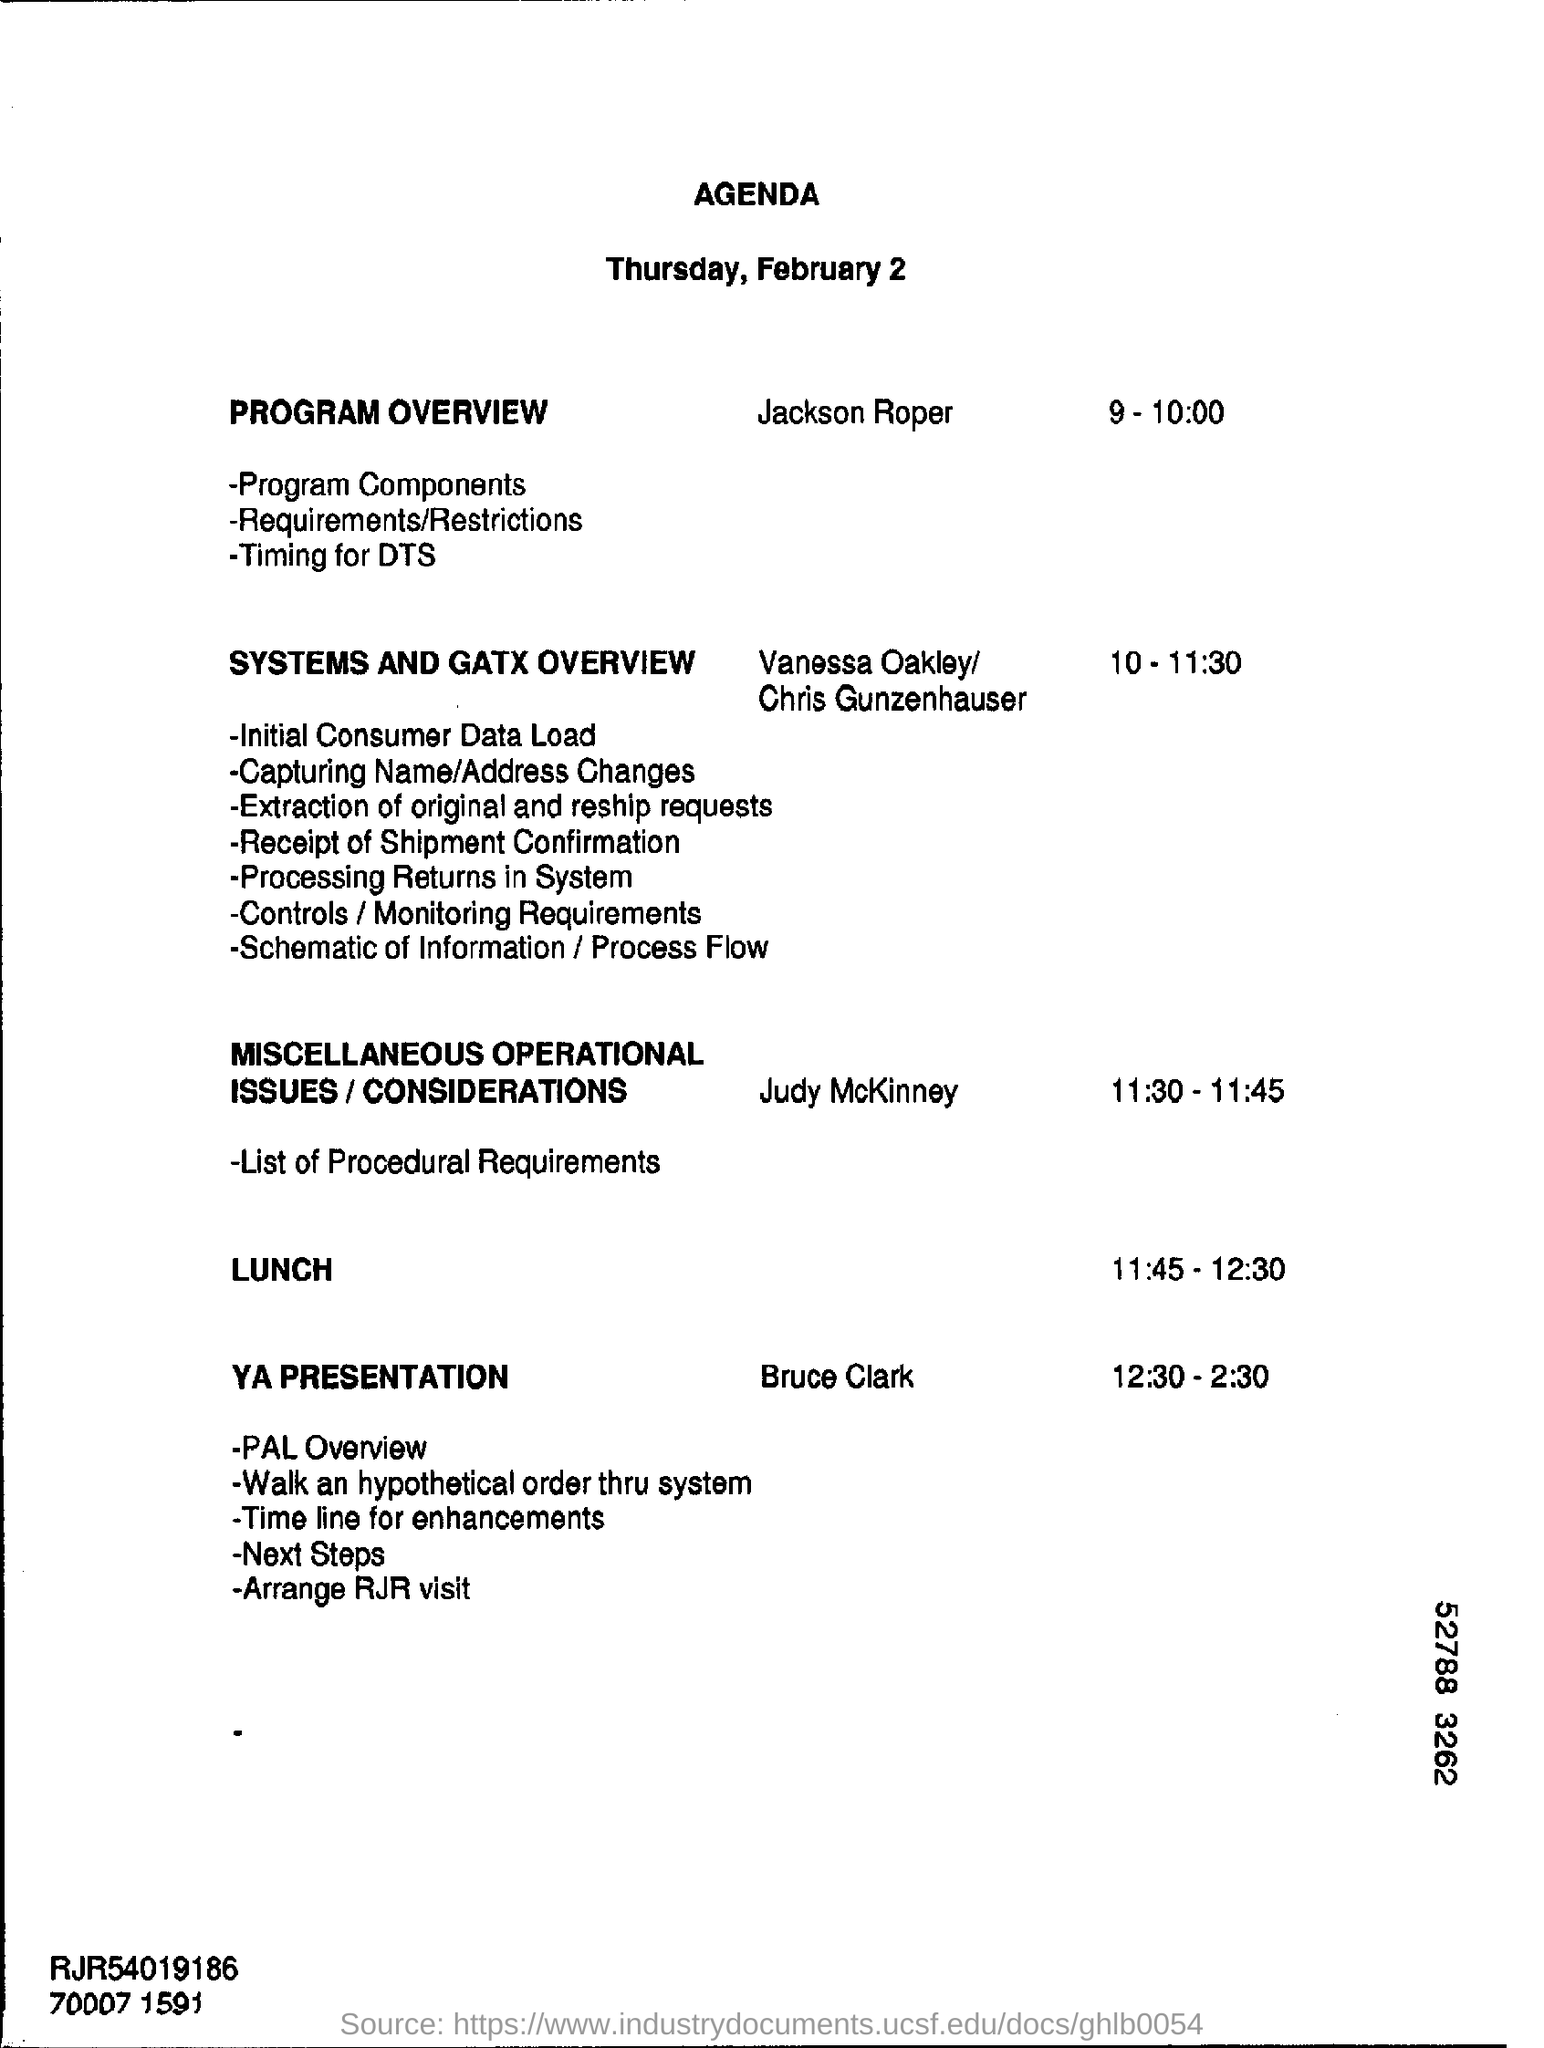Point out several critical features in this image. At 11:45 AM to 12:30 PM, lunch is scheduled. The date mentioned in the given page is February 2. What is the schedule at the time of 10-11:30? The systems and GATX overview. At 9-10:00 PM, the schedule is as follows: a program overview will be provided. 